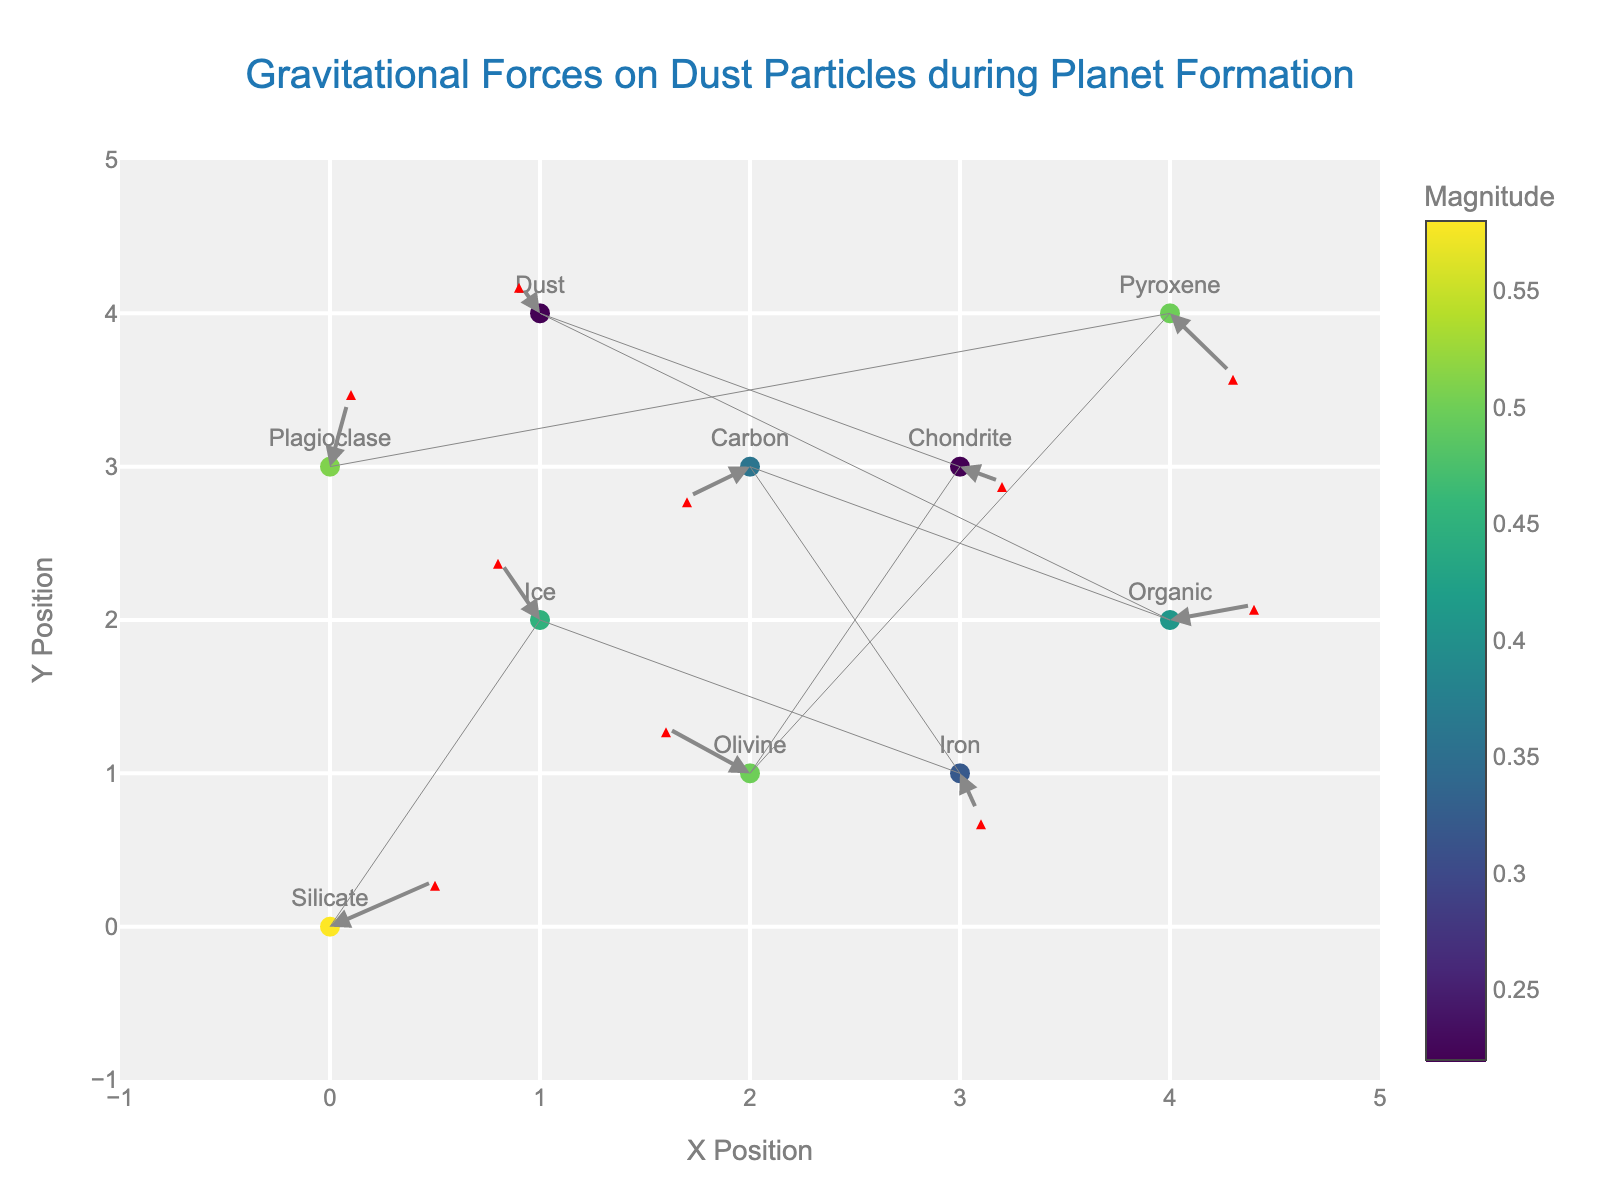what is the title of the figure? The title is displayed at the top center of the figure. It reads 'Gravitational Forces on Dust Particles during Planet Formation'.
Answer: Gravitational Forces on Dust Particles during Planet Formation how many data points are shown in the figure? The figure has markers indicating data points. By counting them, there are 10 data points.
Answer: 10 which particle type has the smallest vector magnitude? By looking at the color scale, the 'Dust' particle type at (1, 4) has the smallest magnitude of 0.22, indicated by the color and the smaller arrow.
Answer: Dust what are the x and y coordinates of the 'Iron' particle? The 'Iron' particle’s position is specified in the labels. It is located at (3, 1).
Answer: (3, 1) which particle type has the largest vector magnitude and what is its value? By observing the color scale and length of the arrows, the 'Silicate' particle type at (0, 0) has the largest magnitude of 0.58.
Answer: Silicate, 0.58 what direction is the vector of 'Olivine' particle pointing? The 'Olivine' particle at (2, 1) has a vector with components (-0.4, 0.3). This points towards the left and slightly upwards.
Answer: Left and slightly upwards compare the vectors of 'Ice' and 'Pyroxene' particles. Which one has a higher magnitude? 'Ice' at (1, 2) has a magnitude of 0.45, and 'Pyroxene' at (4, 4) has a magnitude of 0.5. Therefore, 'Pyroxene' has the higher magnitude.
Answer: Pyroxene what is the average magnitude of the vectors in the figure? Sum the magnitudes of all vectors (0.58 + 0.45 + 0.32 + 0.36 + 0.41 + 0.22 + 0.22 + 0.5 + 0.5 + 0.51) = 4.07 and divide by the number of data points 10, results in an average magnitude of 0.407.
Answer: 0.407 which particle types have vectors pointing downwards (negative y-component)? By examining the vectors, 'Iron' (0.1, -0.3), 'Carbon' (-0.3, -0.2), 'Chondrite' (0.2, -0.1), and 'Pyroxene' (0.3, -0.4) have vectors with negative y-components.
Answer: Iron, Carbon, Chondrite, Pyroxene which particle has the longest horizontal vector component and what is its value? The horizontal vector component (u) is highest for 'Olivine' at (2, 1) with a value of -0.4.
Answer: Olivine, -0.4 